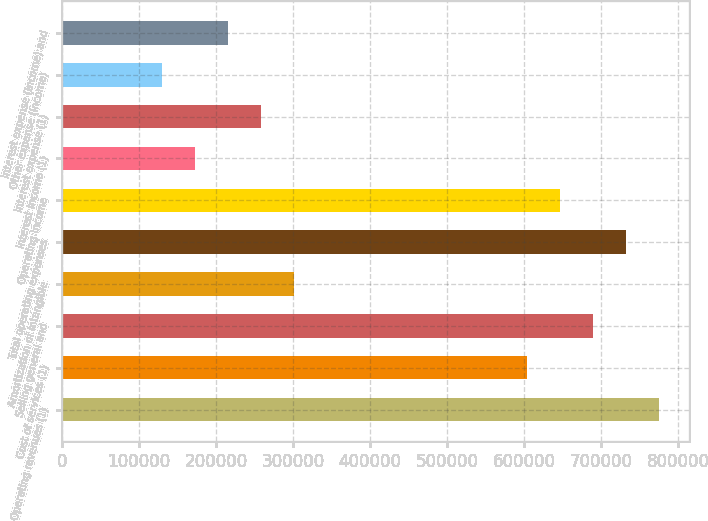<chart> <loc_0><loc_0><loc_500><loc_500><bar_chart><fcel>Operating revenues (1)<fcel>Cost of services (1)<fcel>Selling general and<fcel>Amortization of intangible<fcel>Total operating expenses<fcel>Operating income<fcel>Interest income (1)<fcel>Interest expense (1)<fcel>Other expense (income)<fcel>Interest expense (income) and<nl><fcel>775729<fcel>603345<fcel>689537<fcel>301673<fcel>732633<fcel>646441<fcel>172385<fcel>258577<fcel>129289<fcel>215481<nl></chart> 